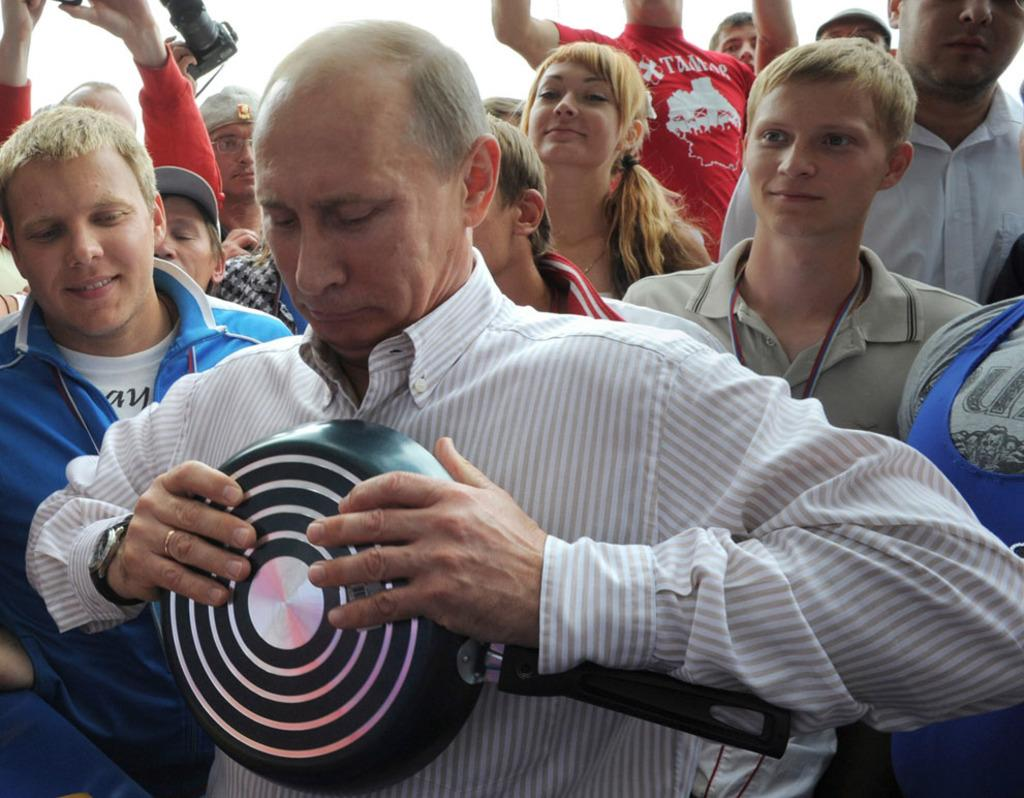What types of individuals are present in the image? There are people in the image, including men and women. Can you describe what one person is doing in the image? One person is holding a pan in their hands. What is the reaction of the people to the prose being read aloud at night in the image? There is no mention of prose being read aloud or any specific time of day in the image, so it is not possible to determine the reaction of the people. 